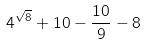<formula> <loc_0><loc_0><loc_500><loc_500>4 ^ { \sqrt { 8 } } + 1 0 - \frac { 1 0 } { 9 } - 8</formula> 